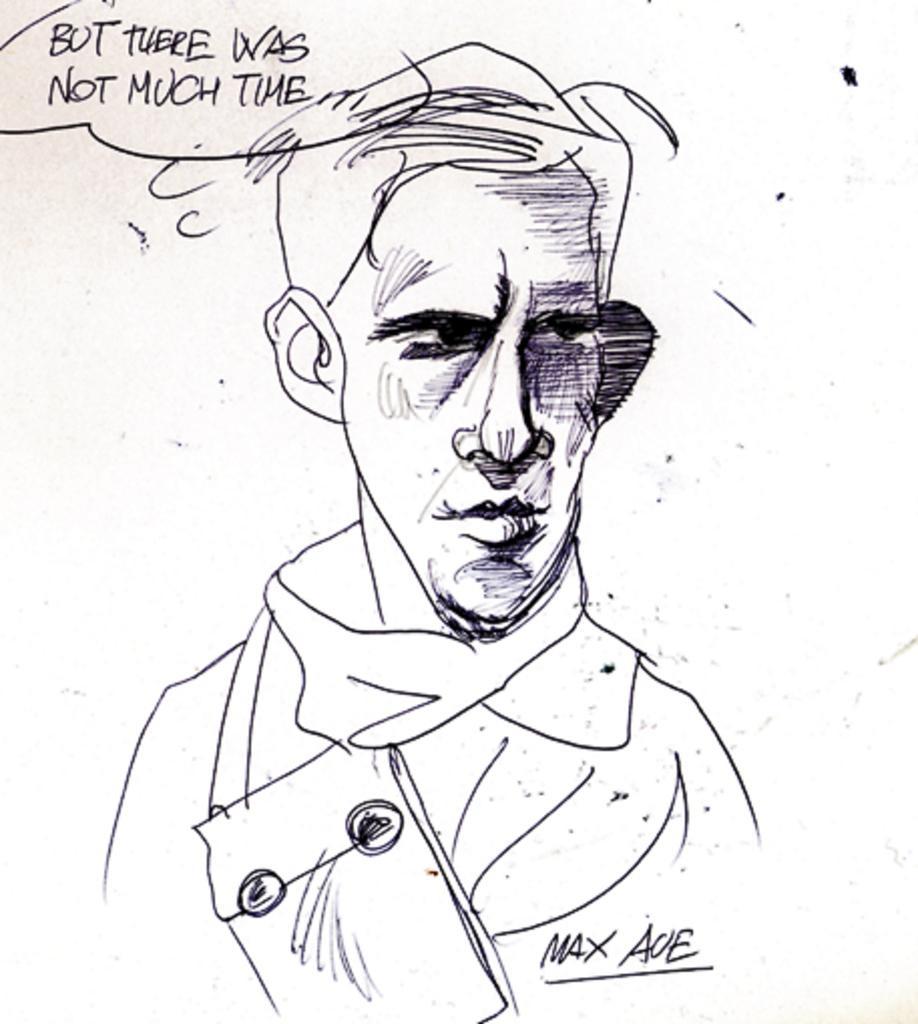Please provide a concise description of this image. In this image I can see the persons art on the white paper. The art is in black color. And I can see but there was not much time is written on the top of the paper. 